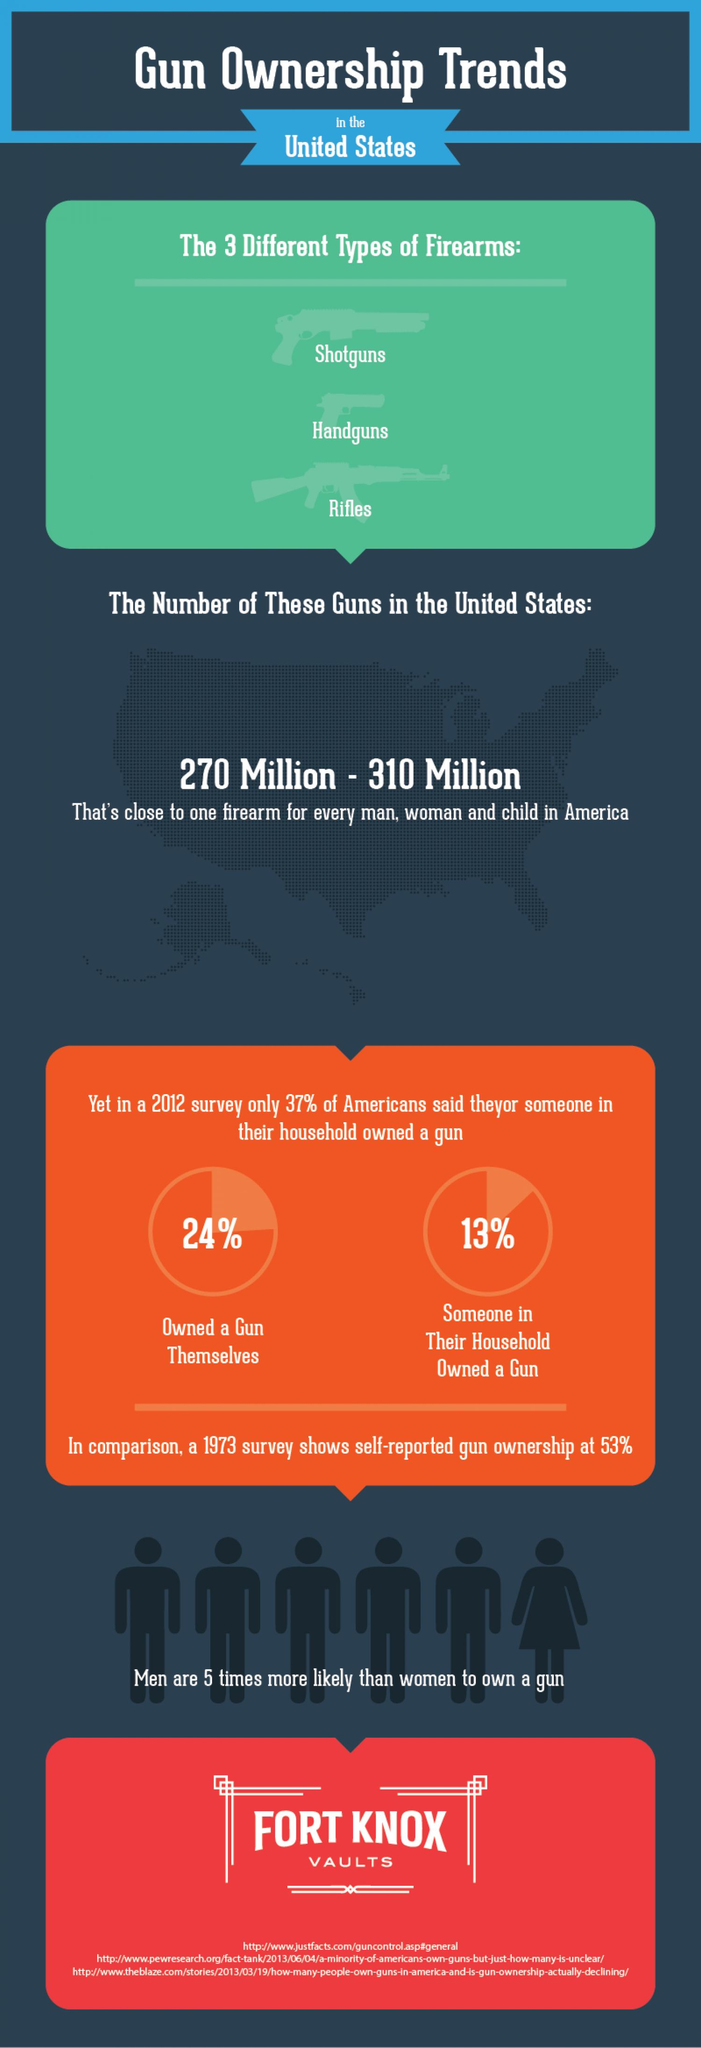Indicate a few pertinent items in this graphic. The gender that is more likely to own a gun in the United States is men. According to a 2012 survey, 76% of Americans do not own a gun themselves. The three types of guns that are widely used in the United States are shotguns, handguns, and rifles. The total number of guns owned by Americans is approximately 270 million to 310 million. 